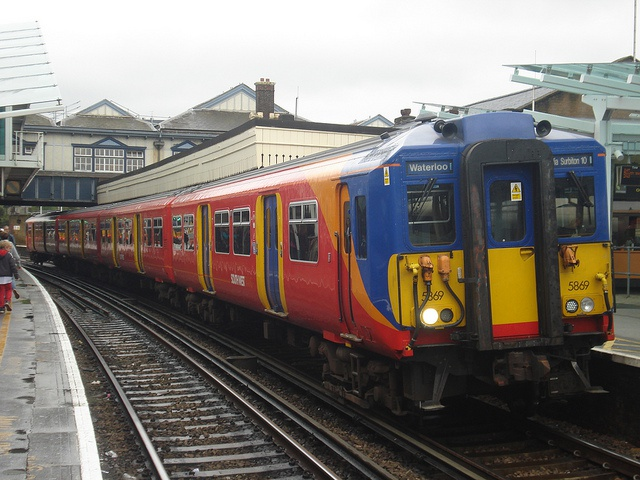Describe the objects in this image and their specific colors. I can see train in white, black, maroon, gray, and brown tones and people in white, black, brown, maroon, and gray tones in this image. 